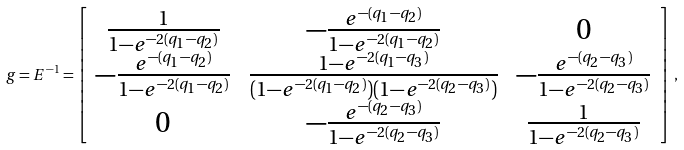<formula> <loc_0><loc_0><loc_500><loc_500>g = E ^ { - 1 } = \left [ \begin{array} { c c c } \frac { 1 } { 1 - e ^ { - 2 ( q _ { 1 } - q _ { 2 } ) } } & - \frac { e ^ { - ( q _ { 1 } - q _ { 2 } ) } } { 1 - e ^ { - 2 ( q _ { 1 } - q _ { 2 } ) } } & 0 \\ - \frac { e ^ { - ( q _ { 1 } - q _ { 2 } ) } } { 1 - e ^ { - 2 ( q _ { 1 } - q _ { 2 } ) } } & \frac { 1 - e ^ { - 2 ( q _ { 1 } - q _ { 3 } ) } } { ( 1 - e ^ { - 2 ( q _ { 1 } - q _ { 2 } ) } ) ( 1 - e ^ { - 2 ( q _ { 2 } - q _ { 3 } ) } ) } & - \frac { e ^ { - ( q _ { 2 } - q _ { 3 } ) } } { 1 - e ^ { - 2 ( q _ { 2 } - q _ { 3 } ) } } \\ 0 & - \frac { e ^ { - ( q _ { 2 } - q _ { 3 } ) } } { 1 - e ^ { - 2 ( q _ { 2 } - q _ { 3 } ) } } & \frac { 1 } { 1 - e ^ { - 2 ( q _ { 2 } - q _ { 3 } ) } } \end{array} \right ] \, ,</formula> 